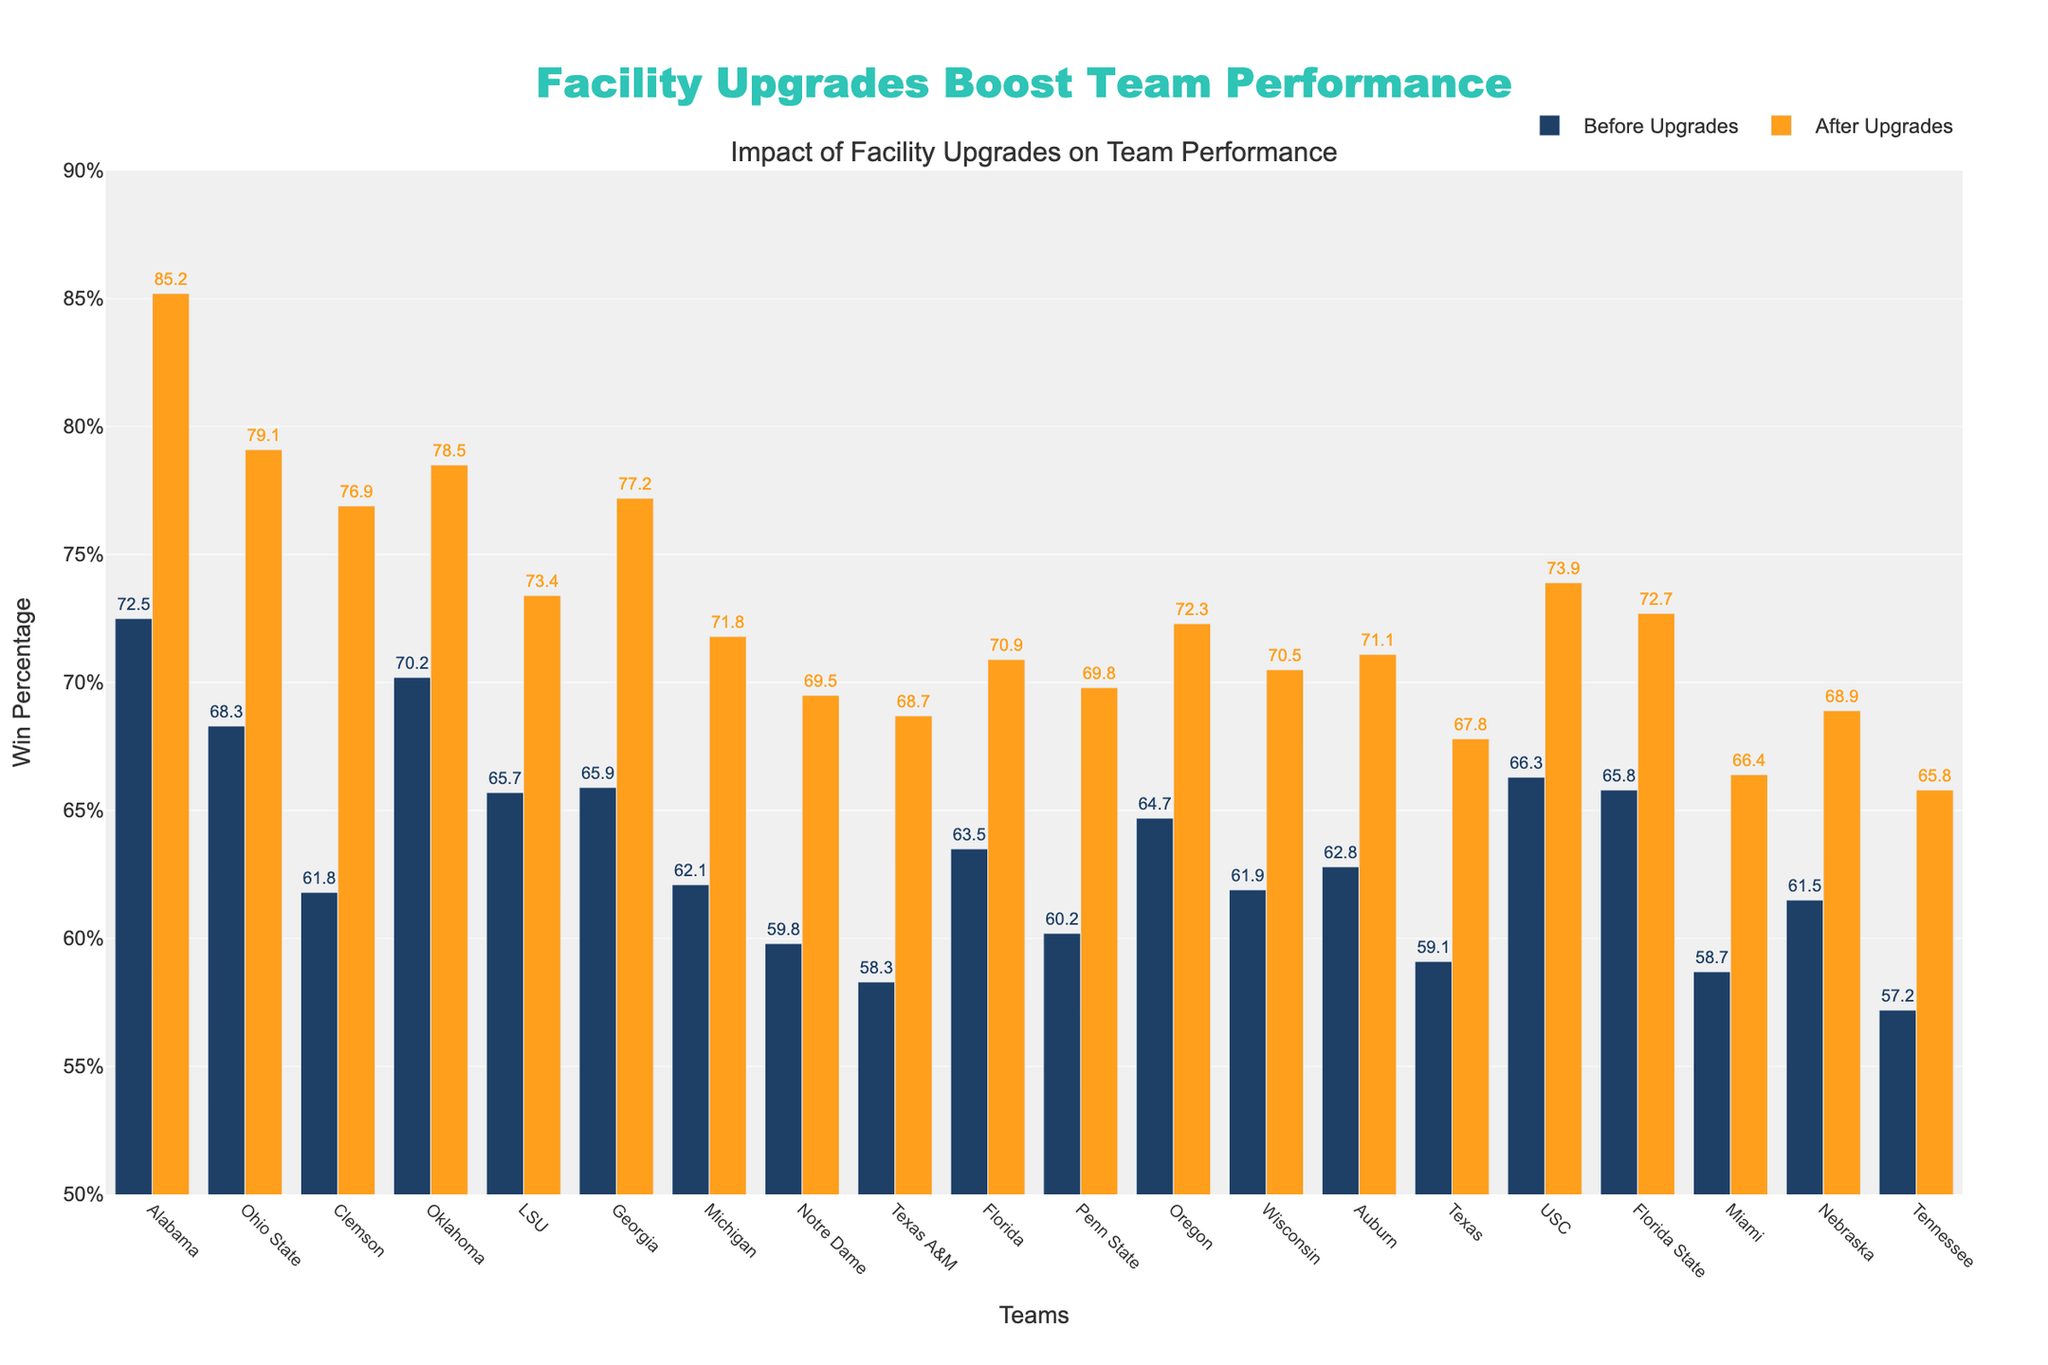Which team had the highest win percentage after the facility upgrades? To find the highest win percentage after the upgrades, we go through all the "Win Percentage After" values and identify the largest one. According to the data, Alabama had the highest win percentage of 85.2% after the upgrades.
Answer: Alabama Which team showed the largest improvement in win percentage after the facility upgrades? To find the largest improvement, subtract "Win Percentage Before" from "Win Percentage After" for each team and identify the maximum difference. Alabama's improvement is 85.2 - 72.5 = 12.7%, which is the largest among all teams.
Answer: Alabama How many teams increased their win percentage by more than 10% after the facility upgrades? To determine the number of teams with an increase greater than 10%, calculate the difference between "Win Percentage Before" and "Win Percentage After" for each team and count the instances where the difference is greater than 10. Alabama and Ohio State both increased their win percentages by more than 10%.
Answer: 2 Did any team decrease in win percentage after the facility upgrades? Inspect the "Win Percentage After" and compare it with "Win Percentage Before" for each team. No team has a lower "Win Percentage After," indicating no team decreased in win percentage.
Answer: No What's the average win percentage after the facility upgrades for all teams? To calculate the average, first sum all the "Win Percentage After" values, then divide by the number of teams. Summing the values gives 1360.8, and there are 20 teams, so the average is 1360.8 / 20.
Answer: 68 Which team had the smallest improvement in win percentage after the facility upgrades? Calculate the difference between "Win Percentage Before" and "Win Percentage After" for each team, then find the smallest positive difference. Miami had the smallest improvement of 66.4 - 58.7 = 7.7%.
Answer: Miami 